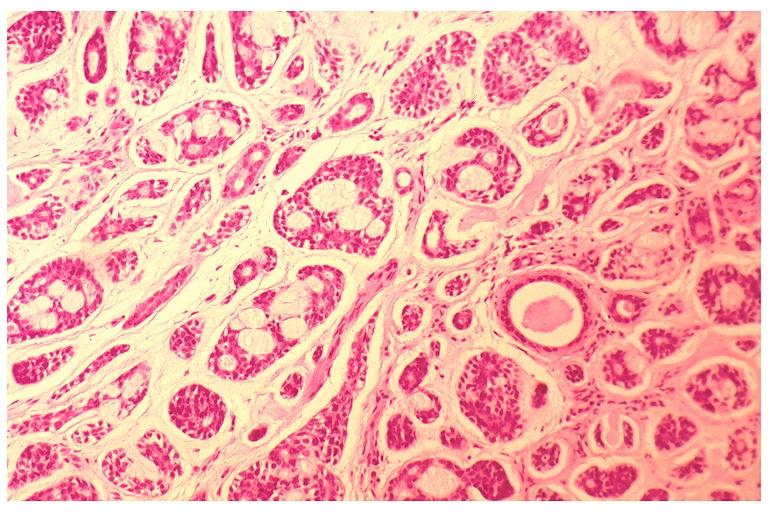does penis show adenoid cystic carcinoma?
Answer the question using a single word or phrase. No 